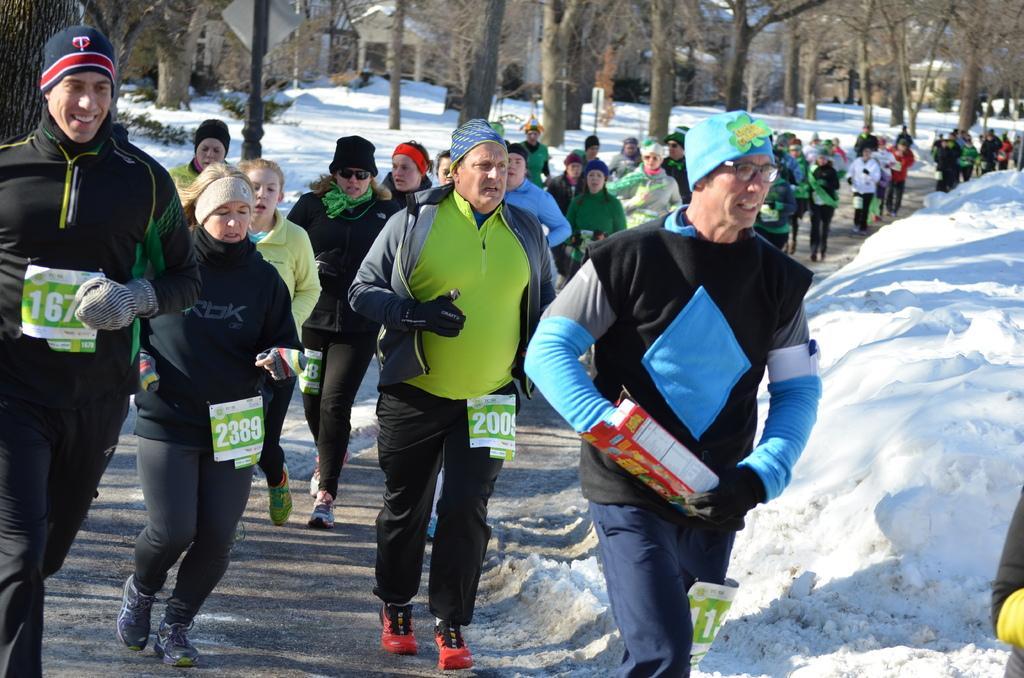How would you summarize this image in a sentence or two? In this image we can see there are trees, snow and houses. And there are some people running on the road and the other person holding a box. 